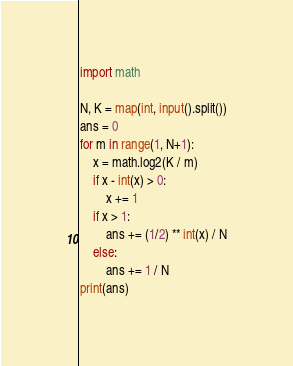<code> <loc_0><loc_0><loc_500><loc_500><_Python_>import math

N, K = map(int, input().split())
ans = 0
for m in range(1, N+1):
    x = math.log2(K / m)
    if x - int(x) > 0:
        x += 1
    if x > 1:
        ans += (1/2) ** int(x) / N
    else:
        ans += 1 / N
print(ans)</code> 